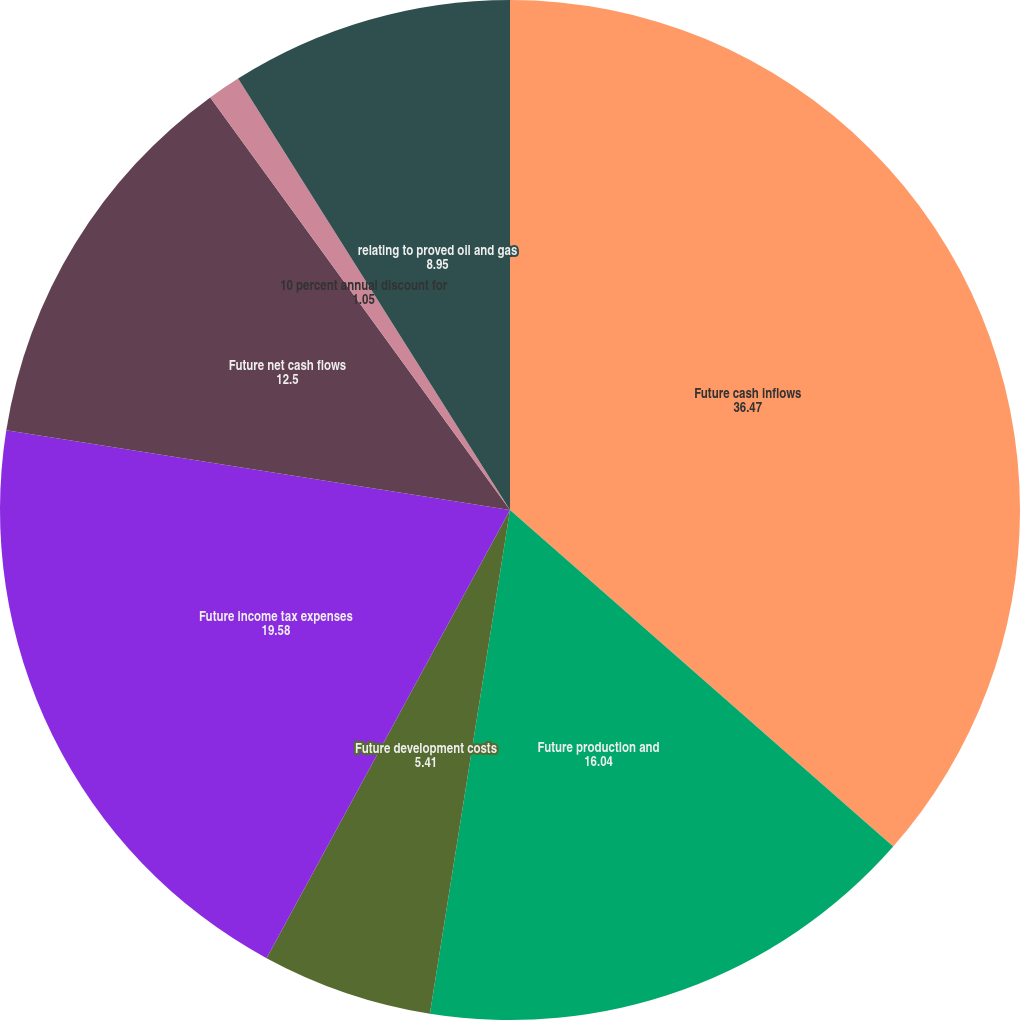<chart> <loc_0><loc_0><loc_500><loc_500><pie_chart><fcel>Future cash inflows<fcel>Future production and<fcel>Future development costs<fcel>Future income tax expenses<fcel>Future net cash flows<fcel>10 percent annual discount for<fcel>relating to proved oil and gas<nl><fcel>36.47%<fcel>16.04%<fcel>5.41%<fcel>19.58%<fcel>12.5%<fcel>1.05%<fcel>8.95%<nl></chart> 